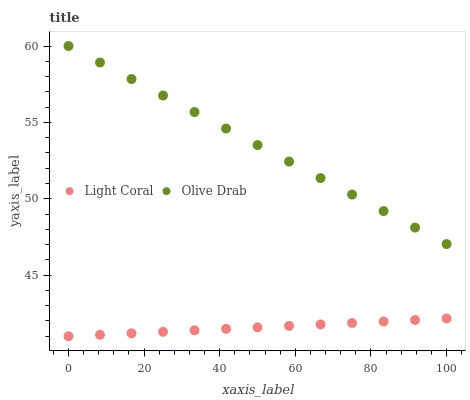Does Light Coral have the minimum area under the curve?
Answer yes or no. Yes. Does Olive Drab have the maximum area under the curve?
Answer yes or no. Yes. Does Olive Drab have the minimum area under the curve?
Answer yes or no. No. Is Light Coral the smoothest?
Answer yes or no. Yes. Is Olive Drab the roughest?
Answer yes or no. Yes. Is Olive Drab the smoothest?
Answer yes or no. No. Does Light Coral have the lowest value?
Answer yes or no. Yes. Does Olive Drab have the lowest value?
Answer yes or no. No. Does Olive Drab have the highest value?
Answer yes or no. Yes. Is Light Coral less than Olive Drab?
Answer yes or no. Yes. Is Olive Drab greater than Light Coral?
Answer yes or no. Yes. Does Light Coral intersect Olive Drab?
Answer yes or no. No. 